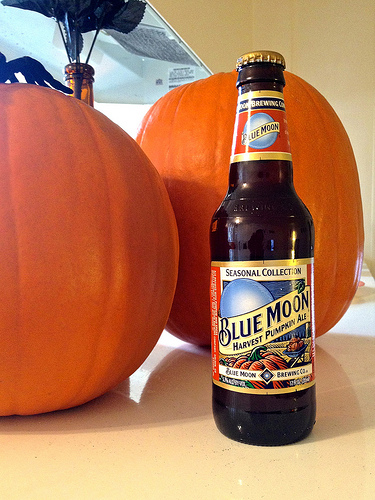<image>
Is there a pumkin behind the bottle? Yes. From this viewpoint, the pumkin is positioned behind the bottle, with the bottle partially or fully occluding the pumkin. Is there a beer to the right of the pumpkin? Yes. From this viewpoint, the beer is positioned to the right side relative to the pumpkin. 